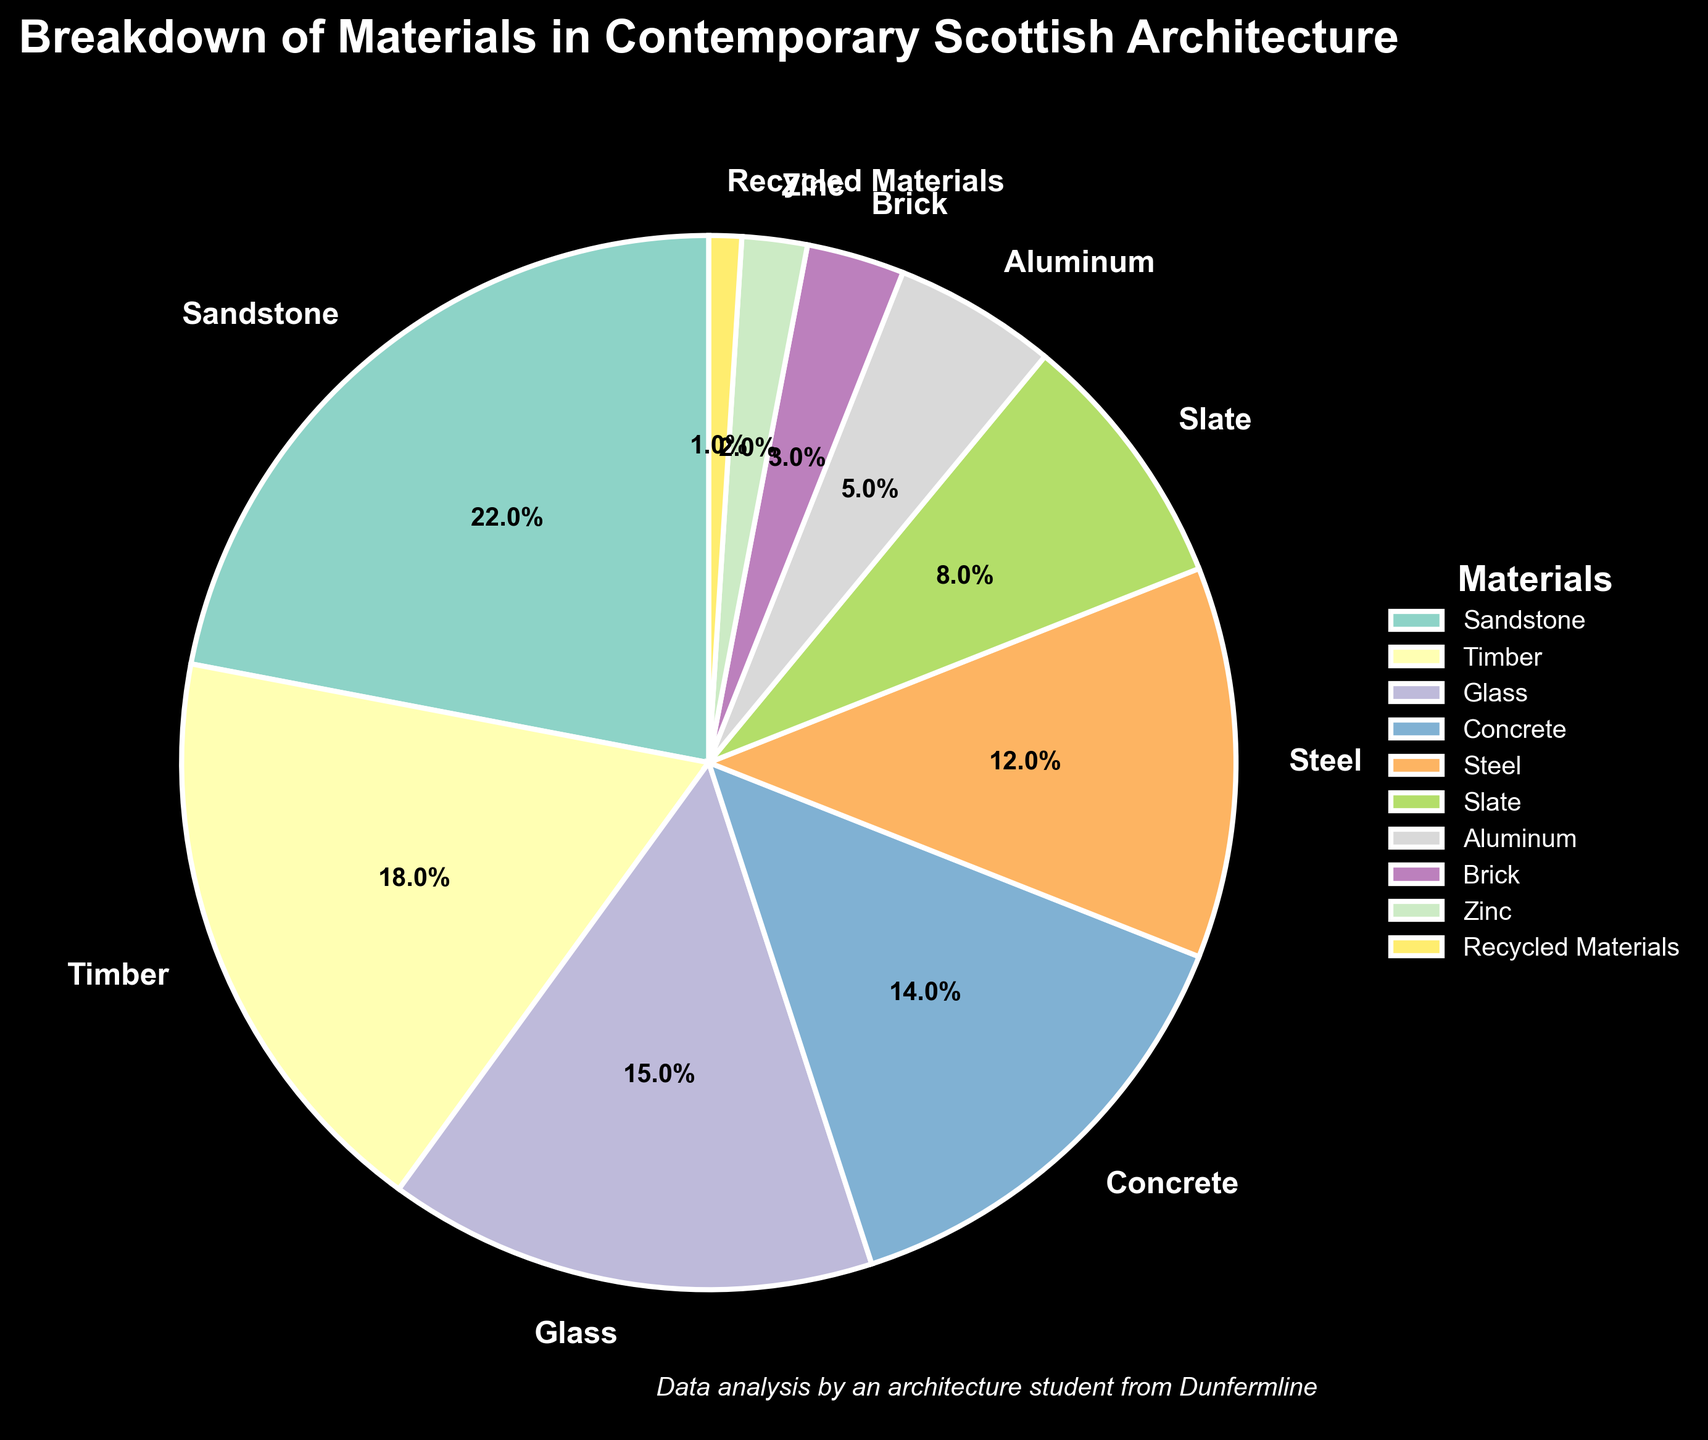What material occupies the largest percentage in contemporary Scottish architecture? According to the figure, Sandstone occupies the largest percentage.
Answer: Sandstone How much more percentage does Timber have compared to Aluminum? Timber is at 18% and Aluminum is at 5%, so the difference is 18 - 5 = 13%.
Answer: 13% What is the combined percentage of Sandstone, Timber, and Glass? Sandstone is 22%, Timber is 18%, and Glass is 15%. Adding these together gives 22 + 18 + 15 = 55%.
Answer: 55% Is the percentage of Steel higher or lower than that of Concrete? The figure shows Steel at 12% and Concrete at 14%. Steel is lower than Concrete.
Answer: Lower Which two materials combined make up nearly a quarter of the total materials used? Slate and Aluminum have percentages of 8% and 5% respectively. Adding these together gives 8 + 5 = 13%, which is not quite a quarter. Instead, we check Timber and Concrete: 18 + 14 = 32%. This exceeds a quarter. Now, checking other pairs: Steel and Slate combined give 12+8 = 20%. This is close to, but not quite a quarter. Calculating the sum of other pairs, the combination of Steel and Concrete is closest: 12+14=26%. Thus, looking for pairs very near but not exceeding 25%, we derive Sandstone and Recycled Materials combined make 23%, Also Timber paired with Aluminum make up 23% Timber and Glass also give a sum close below 25%. Thus answering more than a single pair meeting the condition in nearly a quarter.
Answer: Timber and Concrete If you were to combine the percentages of all materials except Sandstone, Timber, and Glass, what would the total percentage be? First, sum the percentages of Sandstone, Timber, and Glass: 22 + 18 + 15 = 55%. Then, subtract that from 100%: 100 - 55 = 45%.
Answer: 45% Which material is represented by a segment with the smallest percentage in the pie chart? The pie chart shows that Recycled Materials is at 1%, which is the smallest percentage.
Answer: Recycled Materials How does the percentage of Slate compare to that of Brick? The figure shows Slate at 8% and Brick at 3%, so Slate has a higher percentage than Brick.
Answer: Slate has a higher percentage Between Steel and Aluminum, which material has a larger wedge on the pie chart? Steel has 12% while Aluminum has 5%, indicating that Steel has a larger wedge.
Answer: Steel 